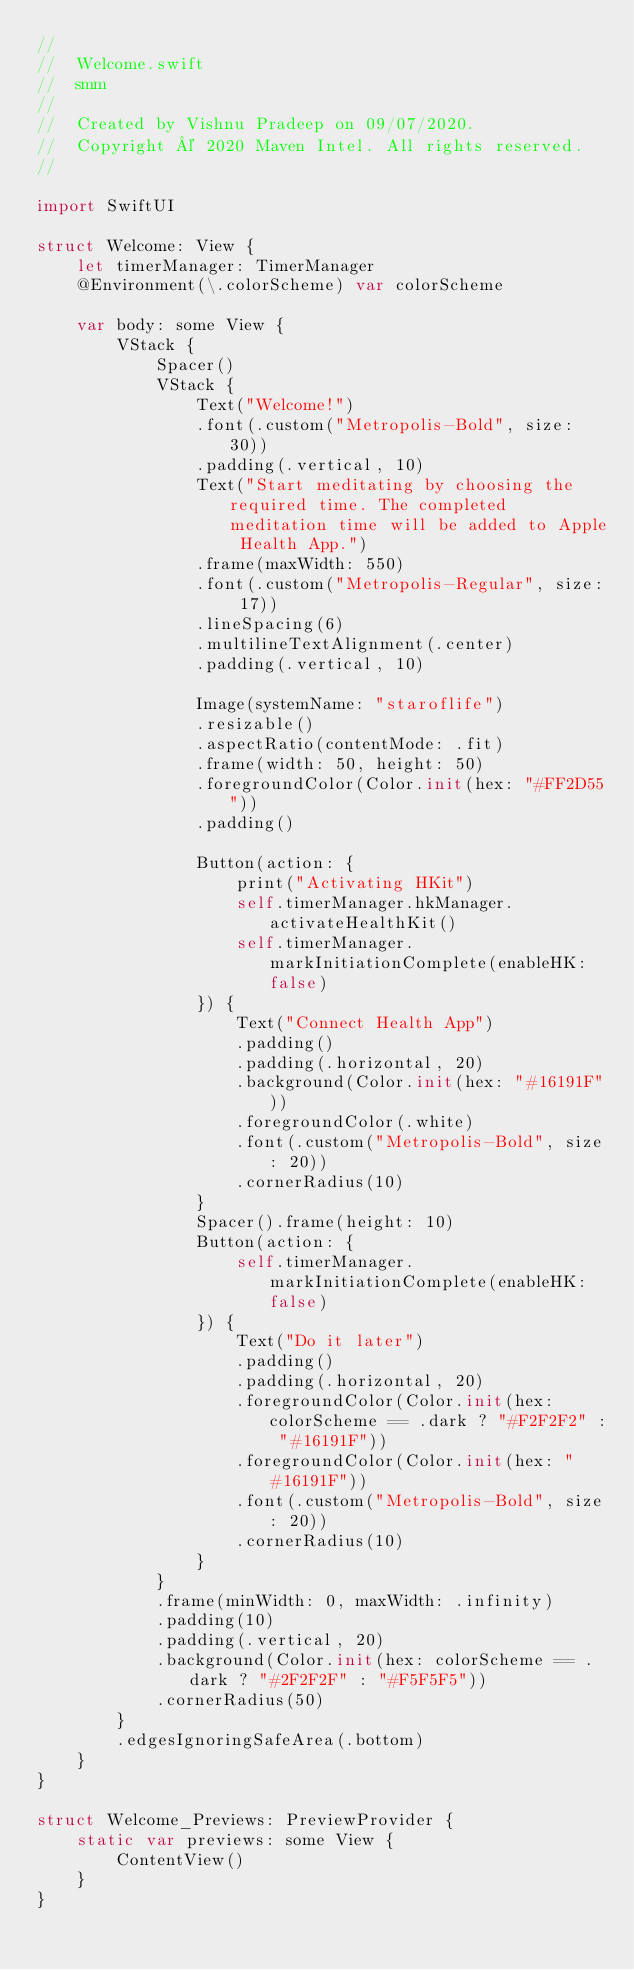Convert code to text. <code><loc_0><loc_0><loc_500><loc_500><_Swift_>//
//  Welcome.swift
//  smm
//
//  Created by Vishnu Pradeep on 09/07/2020.
//  Copyright © 2020 Maven Intel. All rights reserved.
//

import SwiftUI

struct Welcome: View {
    let timerManager: TimerManager
    @Environment(\.colorScheme) var colorScheme
    
    var body: some View {
        VStack {
            Spacer()
            VStack {
                Text("Welcome!")
                .font(.custom("Metropolis-Bold", size: 30))
                .padding(.vertical, 10)
                Text("Start meditating by choosing the required time. The completed meditation time will be added to Apple Health App.")
                .frame(maxWidth: 550)
                .font(.custom("Metropolis-Regular", size: 17))
                .lineSpacing(6)
                .multilineTextAlignment(.center)
                .padding(.vertical, 10)
                
                Image(systemName: "staroflife")
                .resizable()
                .aspectRatio(contentMode: .fit)
                .frame(width: 50, height: 50)
                .foregroundColor(Color.init(hex: "#FF2D55"))
                .padding()
                
                Button(action: {
                    print("Activating HKit")
                    self.timerManager.hkManager.activateHealthKit()
                    self.timerManager.markInitiationComplete(enableHK: false)
                }) {
                    Text("Connect Health App")
                    .padding()
                    .padding(.horizontal, 20)
                    .background(Color.init(hex: "#16191F"))
                    .foregroundColor(.white)
                    .font(.custom("Metropolis-Bold", size: 20))
                    .cornerRadius(10)
                }
                Spacer().frame(height: 10)
                Button(action: {
                    self.timerManager.markInitiationComplete(enableHK: false)
                }) {
                    Text("Do it later")
                    .padding()
                    .padding(.horizontal, 20)
                    .foregroundColor(Color.init(hex: colorScheme == .dark ? "#F2F2F2" : "#16191F"))
                    .foregroundColor(Color.init(hex: "#16191F"))
                    .font(.custom("Metropolis-Bold", size: 20))
                    .cornerRadius(10)
                }
            }
            .frame(minWidth: 0, maxWidth: .infinity)
            .padding(10)
            .padding(.vertical, 20)
            .background(Color.init(hex: colorScheme == .dark ? "#2F2F2F" : "#F5F5F5"))
            .cornerRadius(50)
        }
        .edgesIgnoringSafeArea(.bottom)
    }
}

struct Welcome_Previews: PreviewProvider {
    static var previews: some View {
        ContentView()
    }
}
</code> 